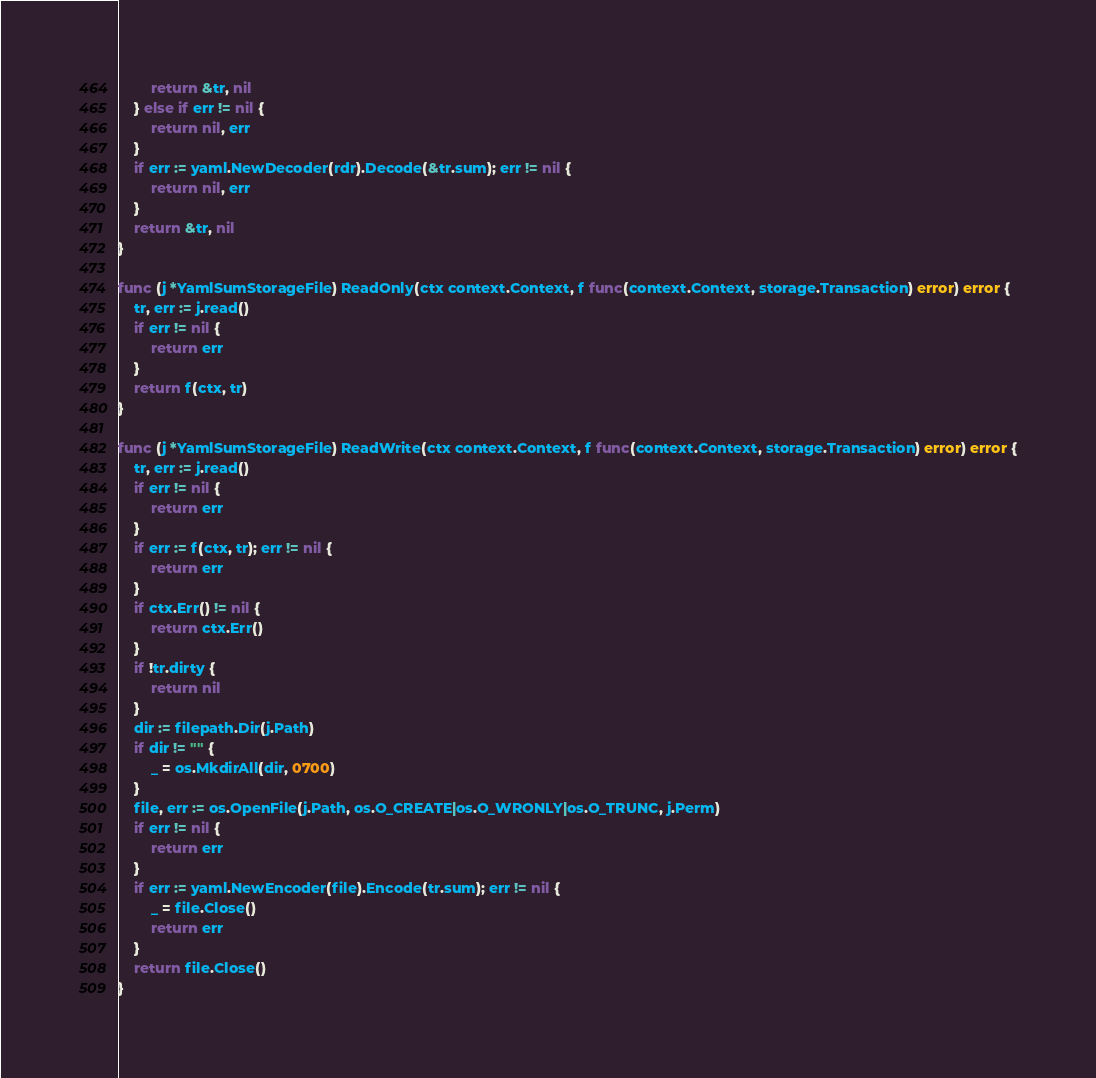<code> <loc_0><loc_0><loc_500><loc_500><_Go_>		return &tr, nil
	} else if err != nil {
		return nil, err
	}
	if err := yaml.NewDecoder(rdr).Decode(&tr.sum); err != nil {
		return nil, err
	}
	return &tr, nil
}

func (j *YamlSumStorageFile) ReadOnly(ctx context.Context, f func(context.Context, storage.Transaction) error) error {
	tr, err := j.read()
	if err != nil {
		return err
	}
	return f(ctx, tr)
}

func (j *YamlSumStorageFile) ReadWrite(ctx context.Context, f func(context.Context, storage.Transaction) error) error {
	tr, err := j.read()
	if err != nil {
		return err
	}
	if err := f(ctx, tr); err != nil {
		return err
	}
	if ctx.Err() != nil {
		return ctx.Err()
	}
	if !tr.dirty {
		return nil
	}
	dir := filepath.Dir(j.Path)
	if dir != "" {
		_ = os.MkdirAll(dir, 0700)
	}
	file, err := os.OpenFile(j.Path, os.O_CREATE|os.O_WRONLY|os.O_TRUNC, j.Perm)
	if err != nil {
		return err
	}
	if err := yaml.NewEncoder(file).Encode(tr.sum); err != nil {
		_ = file.Close()
		return err
	}
	return file.Close()
}
</code> 